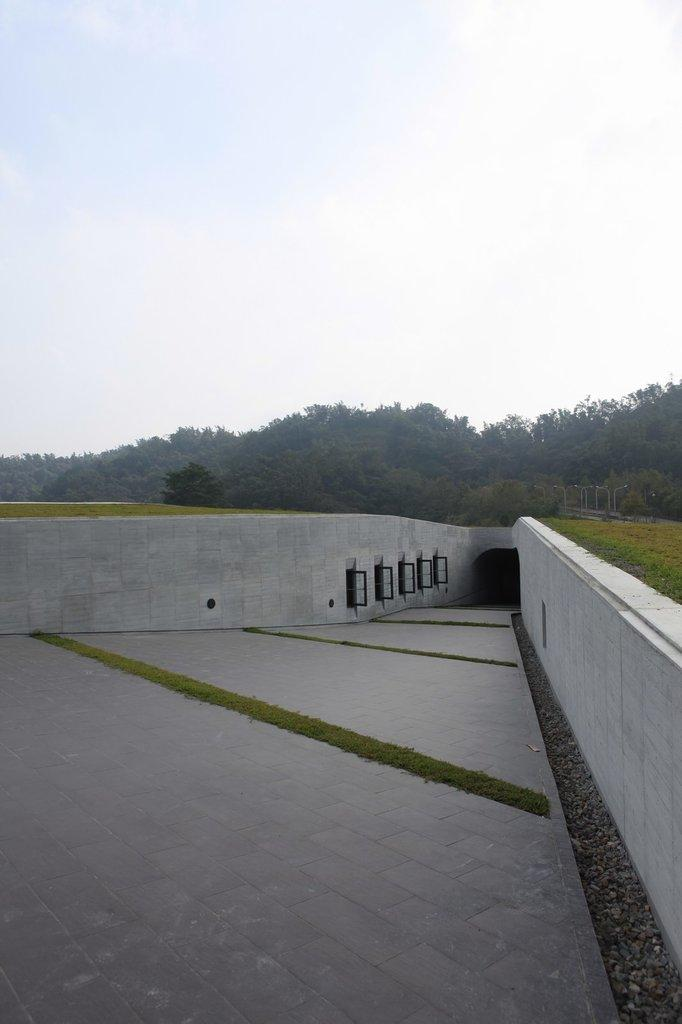What type of surface can be seen at the bottom of the image? There is a floor in the image. What type of vegetation is present in the image? There is grass in the image. What type of structures are present in the image? There are walls and poles in the image. What type of natural elements can be seen in the image? There are trees in the image. What type of objects are present in the image? There are objects in the image. What can be seen in the background of the image? The sky is visible in the background of the image, and there are clouds in the sky. Can you see the person smiling in the image? There is no person present in the image, so it is not possible to see a smile. 